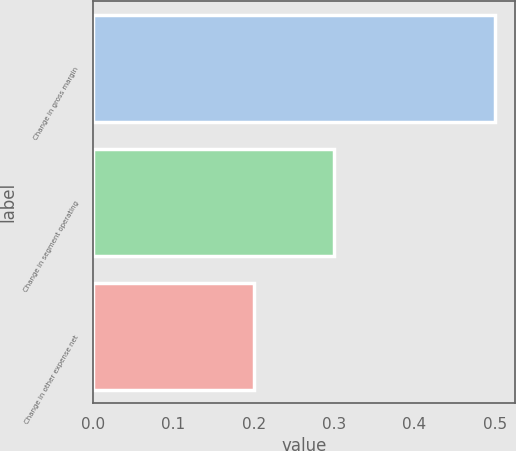Convert chart to OTSL. <chart><loc_0><loc_0><loc_500><loc_500><bar_chart><fcel>Change in gross margin<fcel>Change in segment operating<fcel>Change in other expense net<nl><fcel>0.5<fcel>0.3<fcel>0.2<nl></chart> 